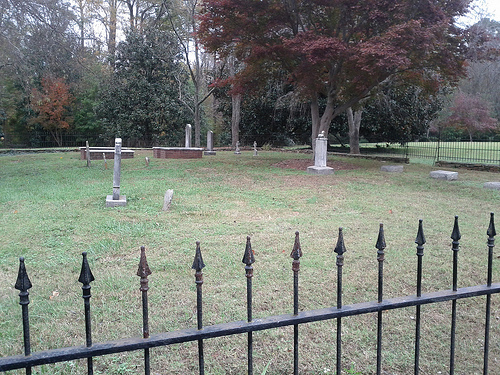<image>
Can you confirm if the tree is behind the fence? Yes. From this viewpoint, the tree is positioned behind the fence, with the fence partially or fully occluding the tree. 